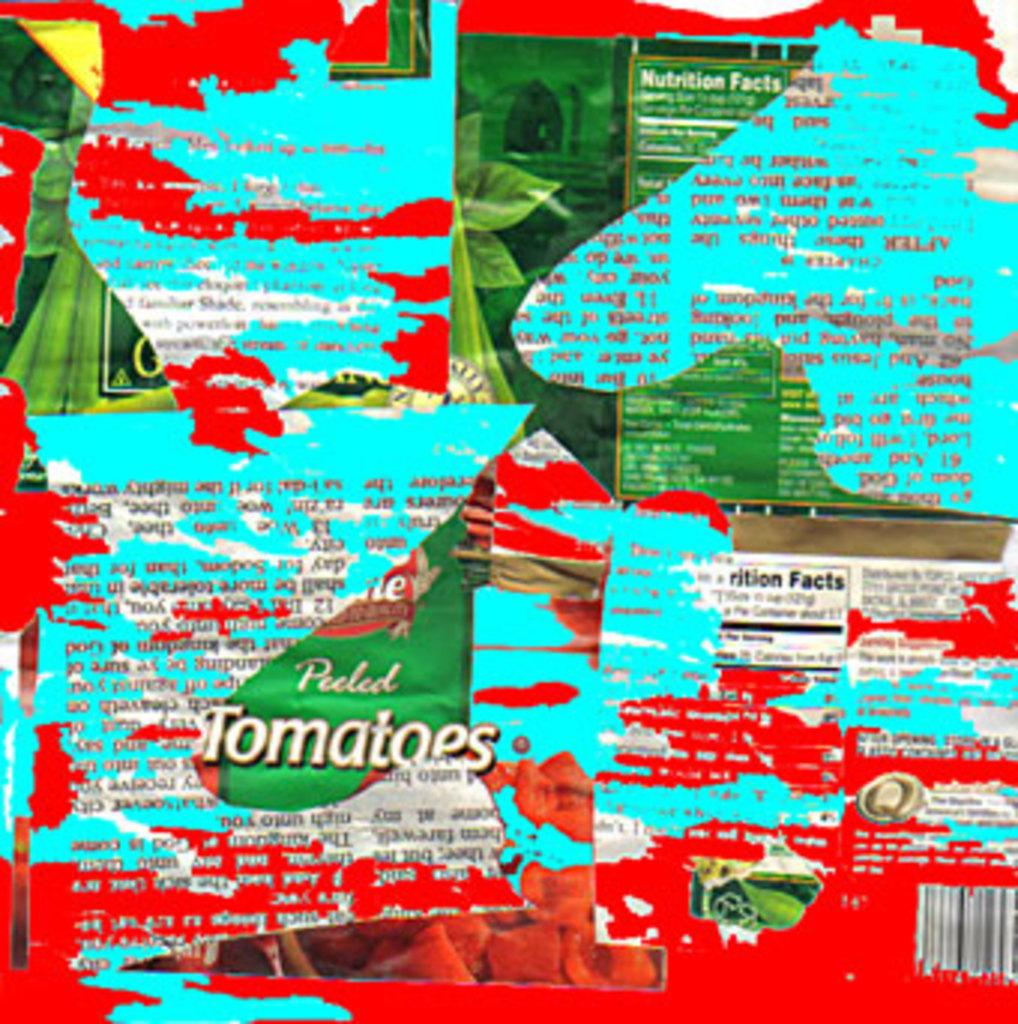What type of information can be found in the image? There is an article with nutrition facts in the image. What type of images are present in the image? There are pictures of leaves and tomatoes in the image. What can be read on the article? There is text written on the article. What type of string is used to tie the tomatoes in the image? There is no string present in the image; the tomatoes are depicted as individual fruits. 